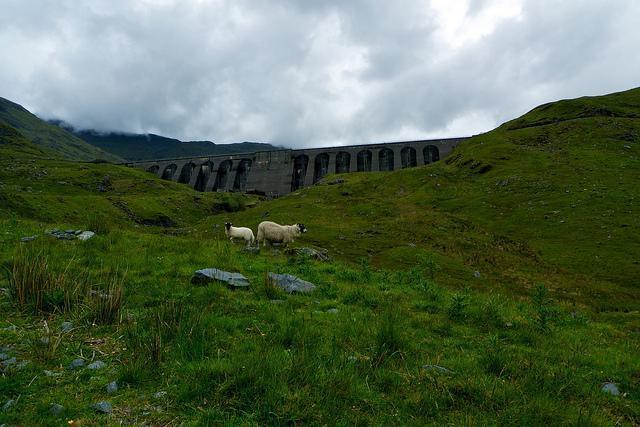How many sheep are presented?
Give a very brief answer. 2. 